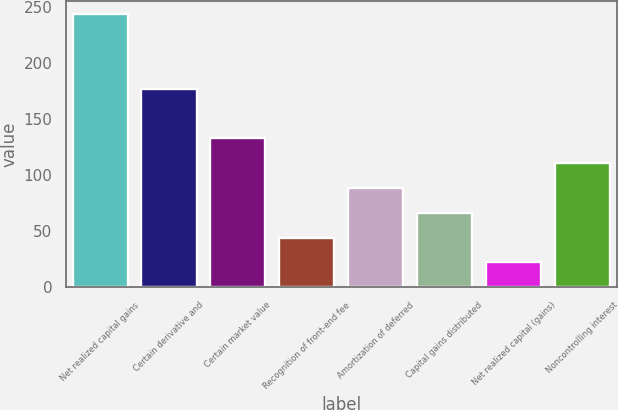Convert chart. <chart><loc_0><loc_0><loc_500><loc_500><bar_chart><fcel>Net realized capital gains<fcel>Certain derivative and<fcel>Certain market value<fcel>Recognition of front-end fee<fcel>Amortization of deferred<fcel>Capital gains distributed<fcel>Net realized capital (gains)<fcel>Noncontrolling interest<nl><fcel>243.64<fcel>177.22<fcel>132.94<fcel>44.38<fcel>88.66<fcel>66.52<fcel>22.24<fcel>110.8<nl></chart> 